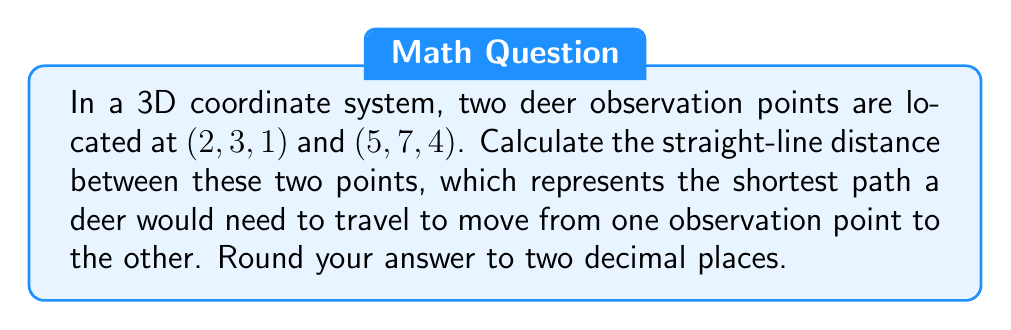Help me with this question. To find the distance between two points in 3D space, we use the distance formula derived from the Pythagorean theorem:

$$d = \sqrt{(x_2 - x_1)^2 + (y_2 - y_1)^2 + (z_2 - z_1)^2}$$

Where $(x_1, y_1, z_1)$ is the first point and $(x_2, y_2, z_2)$ is the second point.

Let's substitute the given coordinates:
$(x_1, y_1, z_1) = (2, 3, 1)$
$(x_2, y_2, z_2) = (5, 7, 4)$

Now, let's calculate each term inside the square root:

1) $(x_2 - x_1)^2 = (5 - 2)^2 = 3^2 = 9$
2) $(y_2 - y_1)^2 = (7 - 3)^2 = 4^2 = 16$
3) $(z_2 - z_1)^2 = (4 - 1)^2 = 3^2 = 9$

Substituting these values into the formula:

$$d = \sqrt{9 + 16 + 9}$$
$$d = \sqrt{34}$$

Using a calculator and rounding to two decimal places:

$$d \approx 5.83$$
Answer: $5.83$ units 